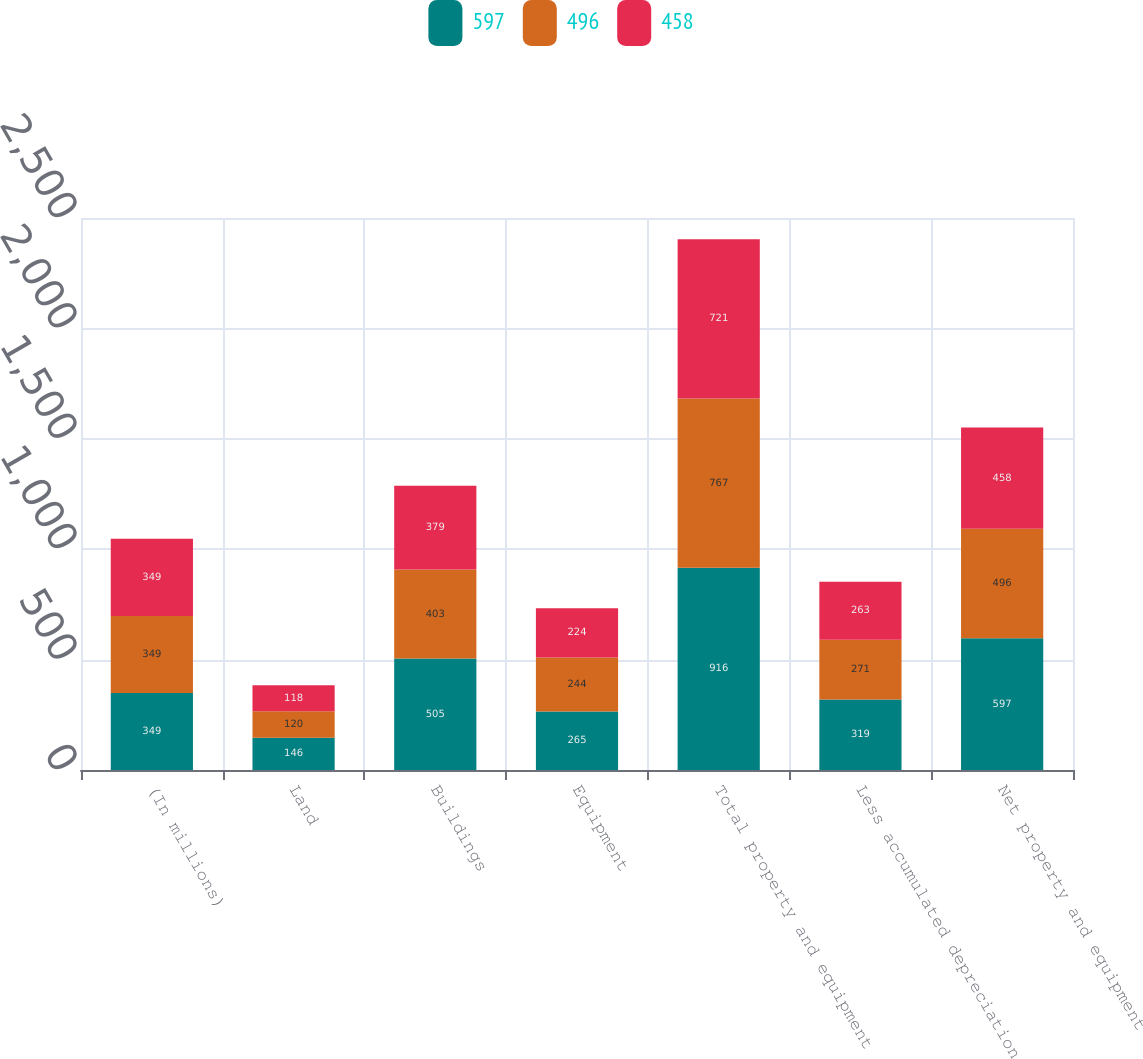<chart> <loc_0><loc_0><loc_500><loc_500><stacked_bar_chart><ecel><fcel>(In millions)<fcel>Land<fcel>Buildings<fcel>Equipment<fcel>Total property and equipment<fcel>Less accumulated depreciation<fcel>Net property and equipment<nl><fcel>597<fcel>349<fcel>146<fcel>505<fcel>265<fcel>916<fcel>319<fcel>597<nl><fcel>496<fcel>349<fcel>120<fcel>403<fcel>244<fcel>767<fcel>271<fcel>496<nl><fcel>458<fcel>349<fcel>118<fcel>379<fcel>224<fcel>721<fcel>263<fcel>458<nl></chart> 